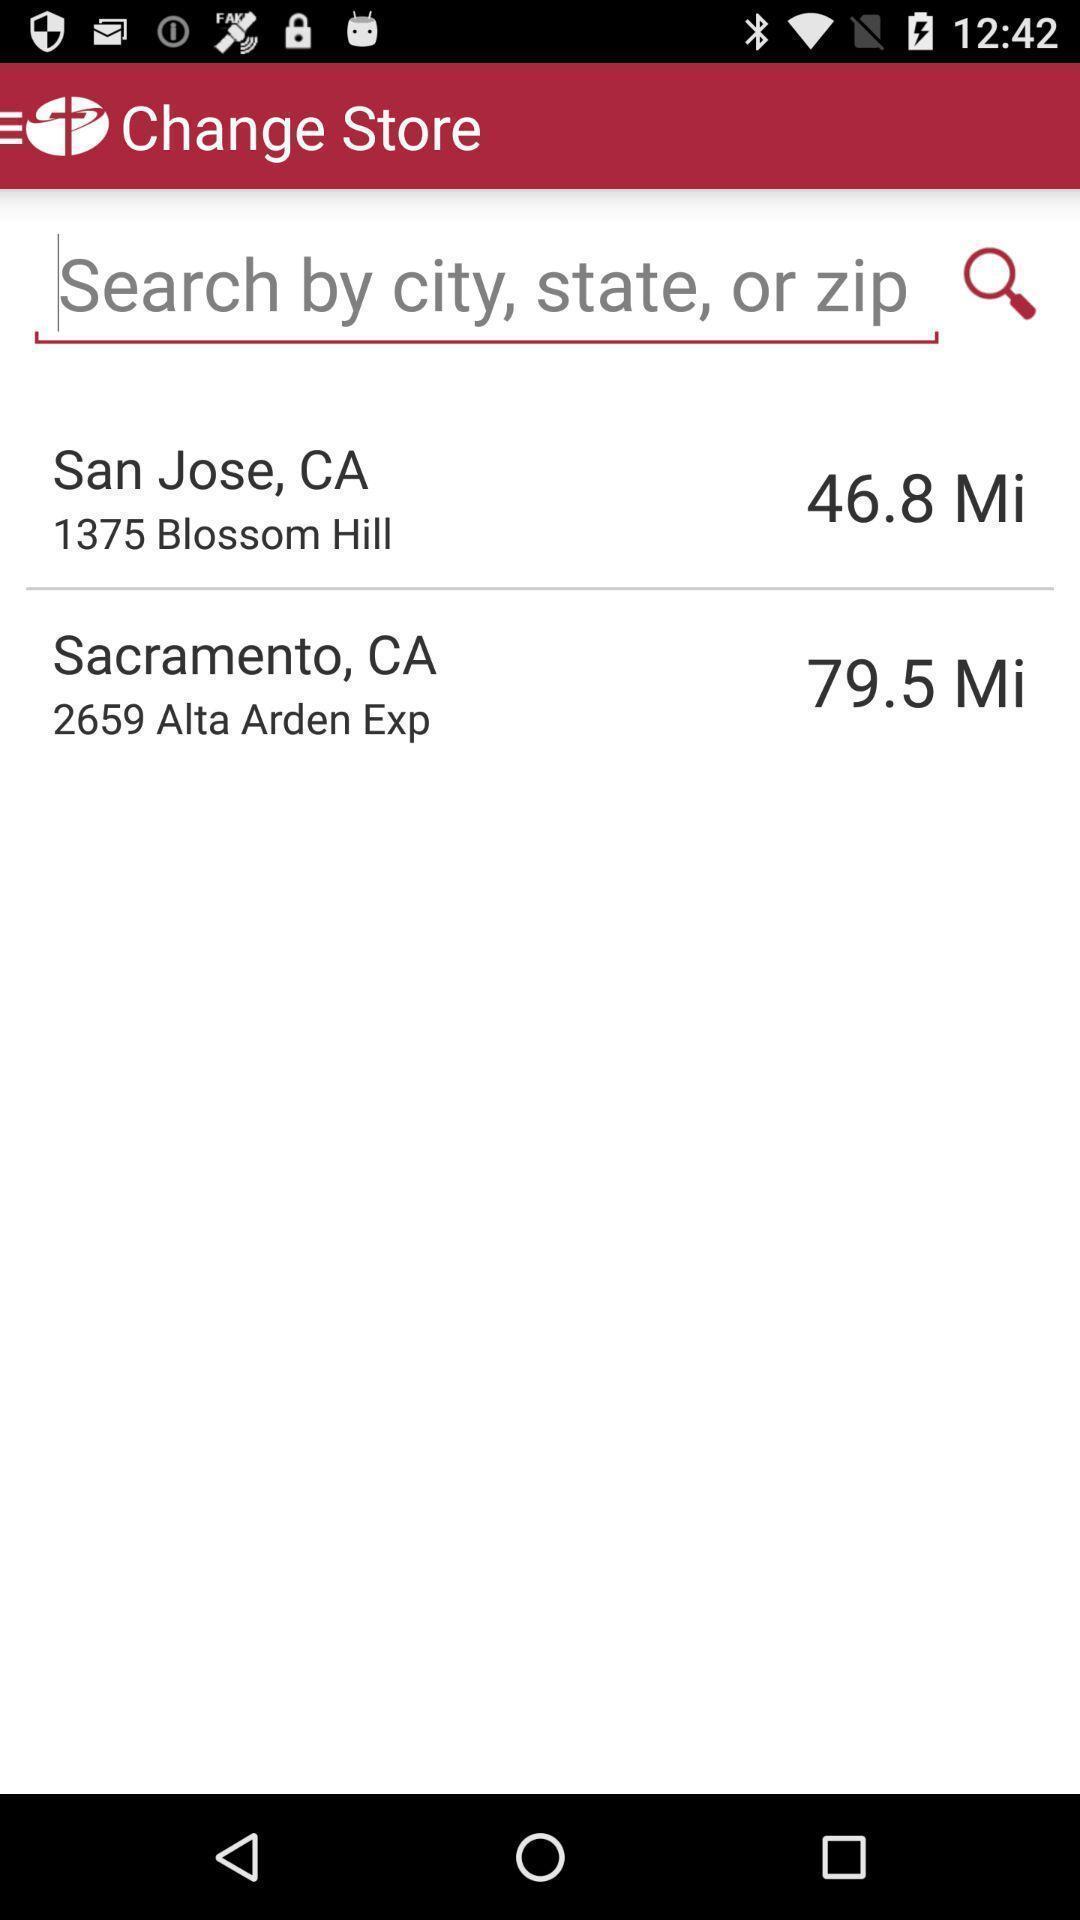Explain the elements present in this screenshot. Search page. 